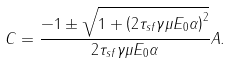Convert formula to latex. <formula><loc_0><loc_0><loc_500><loc_500>C = \frac { - 1 \pm \sqrt { 1 + \left ( 2 \tau _ { s f } \gamma \mu E _ { 0 } \alpha \right ) ^ { 2 } } } { 2 \tau _ { s f } \gamma \mu E _ { 0 } \alpha } A .</formula> 